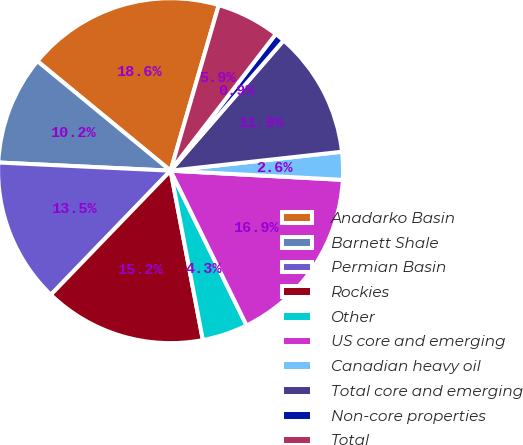<chart> <loc_0><loc_0><loc_500><loc_500><pie_chart><fcel>Anadarko Basin<fcel>Barnett Shale<fcel>Permian Basin<fcel>Rockies<fcel>Other<fcel>US core and emerging<fcel>Canadian heavy oil<fcel>Total core and emerging<fcel>Non-core properties<fcel>Total<nl><fcel>18.55%<fcel>10.2%<fcel>13.54%<fcel>15.21%<fcel>4.27%<fcel>16.88%<fcel>2.6%<fcel>11.87%<fcel>0.93%<fcel>5.94%<nl></chart> 